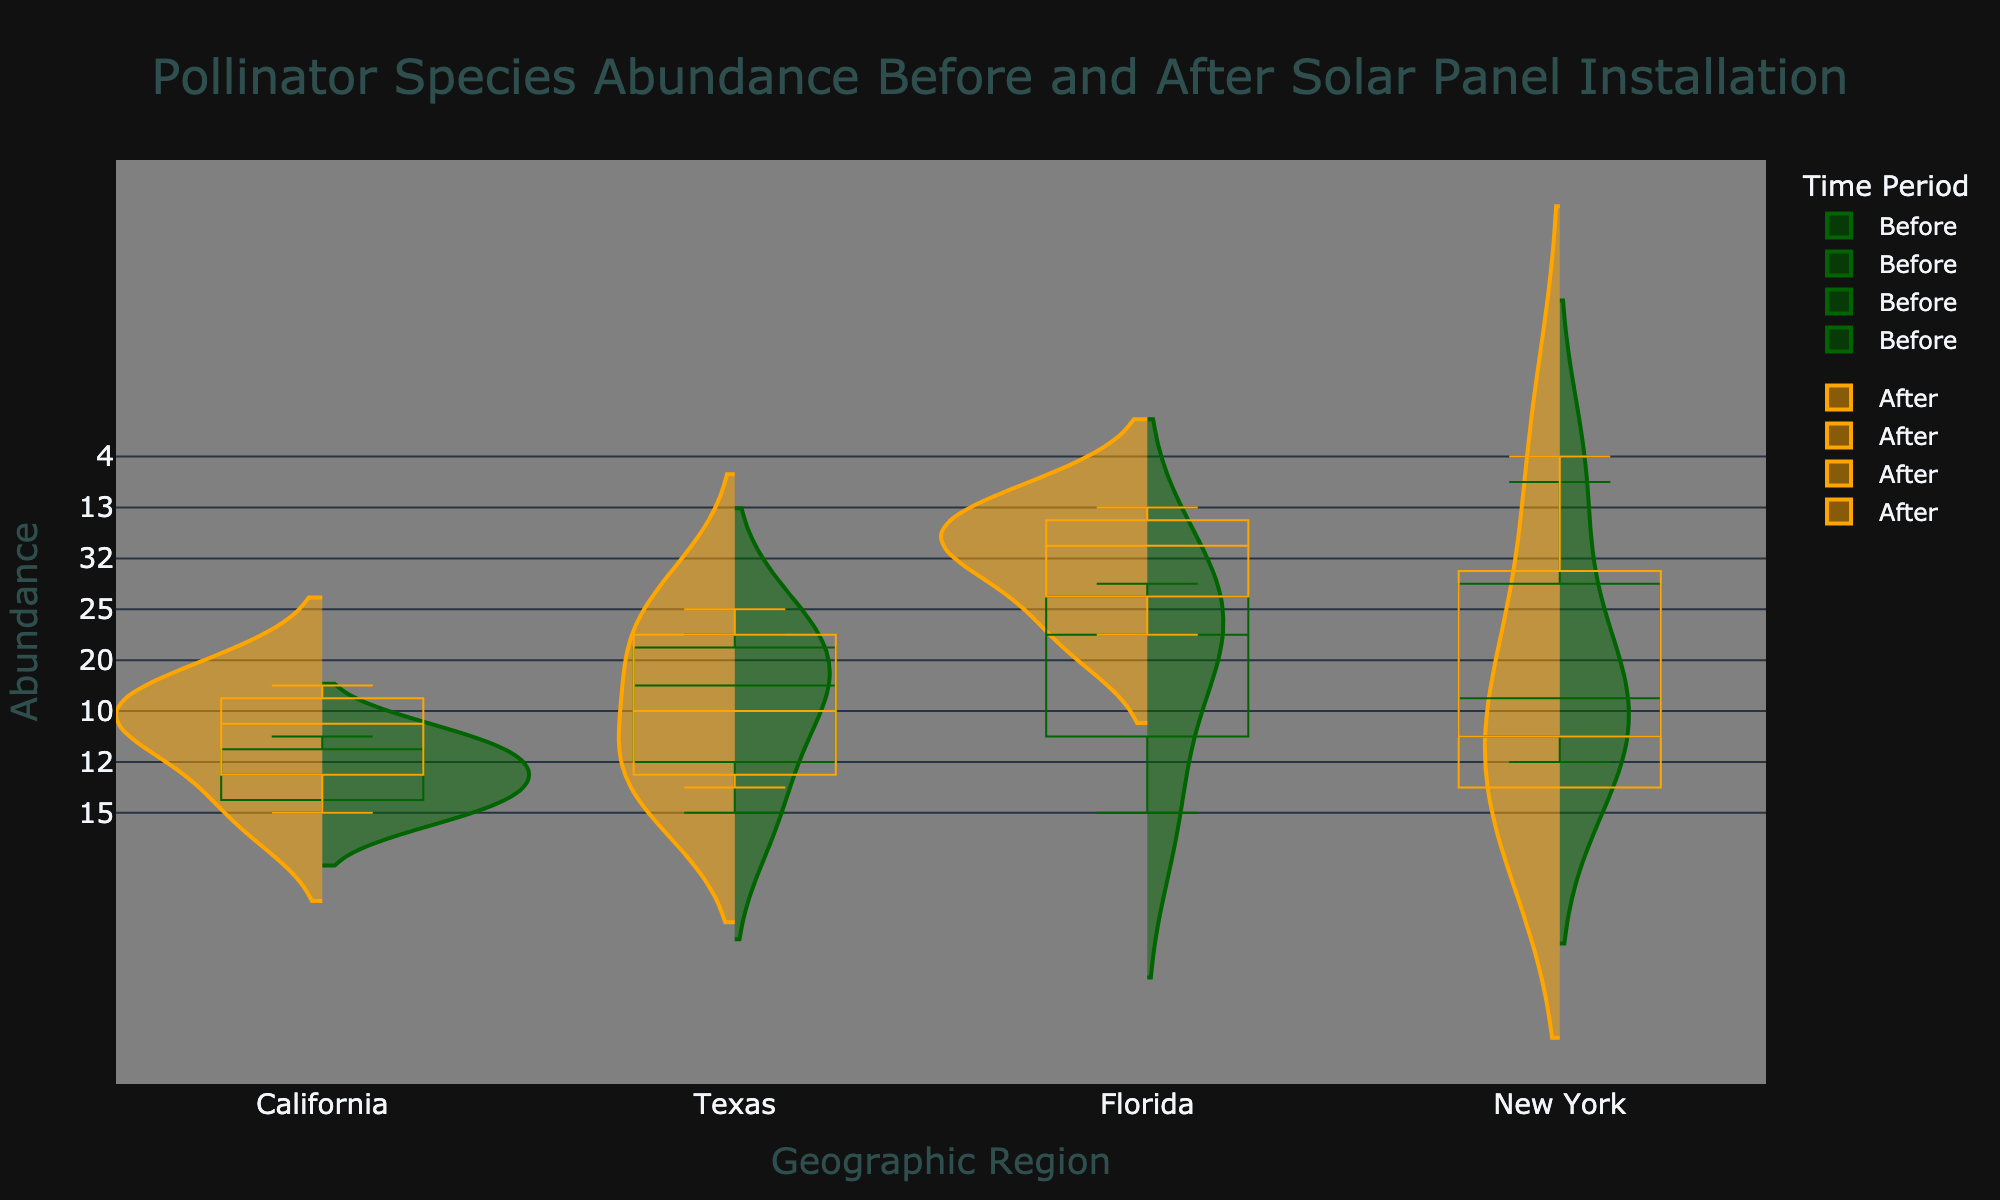What is the title of the plot? The title is located at the top center of the plot and reads "Pollinator Species Abundance Before and After Solar Panel Installation".
Answer: Pollinator Species Abundance Before and After Solar Panel Installation What do the dark green and orange colors represent in the plot? The dark green color represents data from the "Before" time period, and the orange color represents data from the "After" time period as indicated by the legend.
Answer: Dark green: Before, Orange: After Which geographic region has the highest median abundance of pollinator species after solar panel installation? To identify the highest median abundance for the "After" period, look for the center line (median) of the orange box plots. Florida has the highest median abundance visibly.
Answer: Florida How does the abundance of bees in Texas change after solar panel installation? By comparing the dark green (Before) and orange (After) violins and box plots for Texas, we see that the abundance of bees increases from 20 (Before) to 25 (After).
Answer: Increases Compare the interquartile range (IQR) of butterfly abundance in California before and after solar panel installation. The IQR is the range between the first and third quartiles in the box plots. In California, the IQR for butterflies Before (8) is slightly larger than After (7).
Answer: Before > After Which geographic region displays the largest spread of data points for pollinator abundance before solar panel installation? The spread of data points can be assessed by the width and extent of the violins. Florida's green violins before installation show the largest spread.
Answer: Florida Are there any geographic regions where bee abundance decreased after solar panel installation? Bee abundance decreased in New York and California. This can be observed where orange violins are shorter or less dense compared to green violins.
Answer: New York and California What is the difference in median abundance of ladybugs in Florida before and after solar panel installation? The median (center line) for ladybugs in Florida increases from 25 (Before) to 28 (After). The difference is 28 - 25 = 3.
Answer: 3 Which species in New York shows the least change in abundance after solar panel installation? Reviewing the "Before" and "After" box plots for New York, the butterfly species shows the least change, reducing from 6 to 5.
Answer: Butterfly 